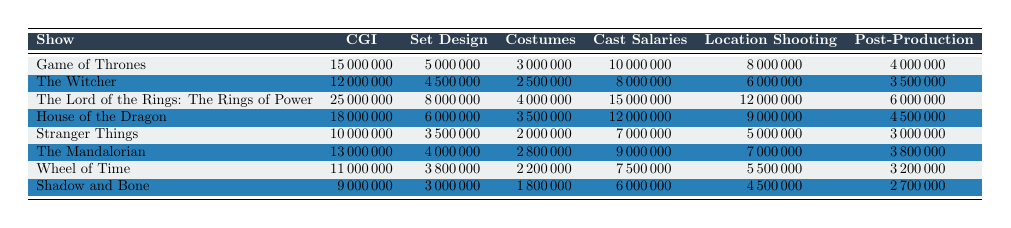What is the production cost for "Game of Thrones"? The row for "Game of Thrones" shows a total CGI cost of 15,000,000, set design of 5,000,000, costumes of 3,000,000, cast salaries of 10,000,000, location shooting of 8,000,000, and post-production of 4,000,000. By adding these values, the total production cost is 15,000,000 + 5,000,000 + 3,000,000 + 10,000,000 + 8,000,000 + 4,000,000 = 45,000,000.
Answer: 45,000,000 Which show has the highest cost for CGI? By examining the CGI column, "The Lord of the Rings: The Rings of Power" has the highest CGI cost at 25,000,000, which is greater than all other shows listed.
Answer: The Lord of the Rings: The Rings of Power What is the total cost of costumes across all shows? To find the total costume cost, we add the values: 3,000,000 (Game of Thrones) + 2,500,000 (The Witcher) + 4,000,000 (The Lord of the Rings: The Rings of Power) + 3,500,000 (House of the Dragon) + 2,000,000 (Stranger Things) + 2,800,000 (The Mandalorian) + 2,200,000 (Wheel of Time) + 1,800,000 (Shadow and Bone) = 22,000,000.
Answer: 22,000,000 Is the total production cost for "The Mandalorian" less than 50 million? The total production cost for "The Mandalorian" is calculated as follows: 13,000,000 (CGI) + 4,000,000 (Set Design) + 2,800,000 (Costumes) + 9,000,000 (Cast Salaries) + 7,000,000 (Location Shooting) + 3,800,000 (Post-Production) = 39,600,000. Since 39,600,000 is less than 50,000,000, the statement is true.
Answer: Yes What is the average location shooting cost across all shows? We calculate the average location shooting cost by summing the location costs: 8,000,000 (Game of Thrones) + 6,000,000 (The Witcher) + 12,000,000 (The Lord of the Rings: The Rings of Power) + 9,000,000 (House of the Dragon) + 5,000,000 (Stranger Things) + 7,000,000 (The Mandalorian) + 5,500,000 (Wheel of Time) + 4,500,000 (Shadow and Bone) = 57,000,000. There are 8 shows, so the average is 57,000,000 / 8 = 7,125,000.
Answer: 7,125,000 Which show has the highest expense in location shooting as a percentage of its total production cost? For each show, we calculate the percentage of location shooting versus total production cost. For example, for "Game of Thrones" the location shooting cost is 8,000,000, so percentage = (8,000,000 / 45,000,000) * 100 = 17.78%. Calculating this for all shows, we find that "The Lord of the Rings: The Rings of Power" has the highest percentage with location shooting cost of 12,000,000 and total production cost of 65,000,000, leading to a percentage of (12,000,000 / 65,000,000) * 100 = 18.46%.
Answer: The Lord of the Rings: The Rings of Power 